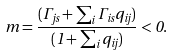<formula> <loc_0><loc_0><loc_500><loc_500>m = \frac { ( \Gamma _ { j s } + \sum _ { i } \Gamma _ { i s } q _ { i j } ) } { ( 1 + \sum _ { i } q _ { i j } ) } < 0 .</formula> 